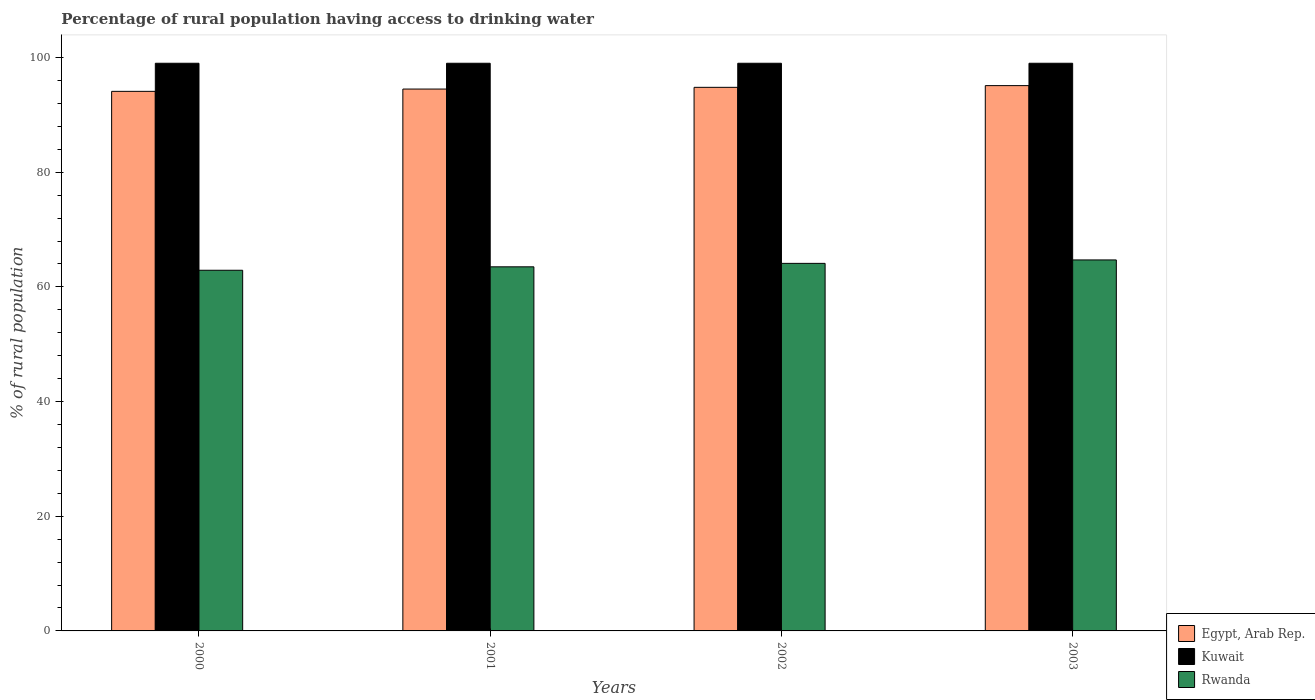How many different coloured bars are there?
Make the answer very short. 3. How many groups of bars are there?
Offer a very short reply. 4. How many bars are there on the 2nd tick from the left?
Your answer should be very brief. 3. How many bars are there on the 1st tick from the right?
Your answer should be compact. 3. In how many cases, is the number of bars for a given year not equal to the number of legend labels?
Ensure brevity in your answer.  0. What is the percentage of rural population having access to drinking water in Kuwait in 2001?
Your response must be concise. 99. Across all years, what is the maximum percentage of rural population having access to drinking water in Rwanda?
Your answer should be compact. 64.7. Across all years, what is the minimum percentage of rural population having access to drinking water in Kuwait?
Offer a very short reply. 99. What is the total percentage of rural population having access to drinking water in Egypt, Arab Rep. in the graph?
Ensure brevity in your answer.  378.5. What is the difference between the percentage of rural population having access to drinking water in Kuwait in 2001 and that in 2002?
Provide a short and direct response. 0. What is the difference between the percentage of rural population having access to drinking water in Kuwait in 2003 and the percentage of rural population having access to drinking water in Egypt, Arab Rep. in 2002?
Your response must be concise. 4.2. In the year 2002, what is the difference between the percentage of rural population having access to drinking water in Rwanda and percentage of rural population having access to drinking water in Kuwait?
Offer a very short reply. -34.9. What is the ratio of the percentage of rural population having access to drinking water in Rwanda in 2000 to that in 2003?
Your response must be concise. 0.97. Is the difference between the percentage of rural population having access to drinking water in Rwanda in 2000 and 2001 greater than the difference between the percentage of rural population having access to drinking water in Kuwait in 2000 and 2001?
Offer a very short reply. No. What is the difference between the highest and the second highest percentage of rural population having access to drinking water in Egypt, Arab Rep.?
Offer a very short reply. 0.3. What does the 2nd bar from the left in 2000 represents?
Provide a succinct answer. Kuwait. What does the 1st bar from the right in 2003 represents?
Keep it short and to the point. Rwanda. How many years are there in the graph?
Offer a terse response. 4. Are the values on the major ticks of Y-axis written in scientific E-notation?
Provide a succinct answer. No. Does the graph contain any zero values?
Your response must be concise. No. Does the graph contain grids?
Your response must be concise. No. How many legend labels are there?
Your answer should be compact. 3. What is the title of the graph?
Offer a terse response. Percentage of rural population having access to drinking water. Does "Samoa" appear as one of the legend labels in the graph?
Offer a very short reply. No. What is the label or title of the Y-axis?
Provide a succinct answer. % of rural population. What is the % of rural population of Egypt, Arab Rep. in 2000?
Provide a succinct answer. 94.1. What is the % of rural population in Kuwait in 2000?
Offer a terse response. 99. What is the % of rural population in Rwanda in 2000?
Provide a short and direct response. 62.9. What is the % of rural population of Egypt, Arab Rep. in 2001?
Offer a very short reply. 94.5. What is the % of rural population of Kuwait in 2001?
Your response must be concise. 99. What is the % of rural population in Rwanda in 2001?
Keep it short and to the point. 63.5. What is the % of rural population of Egypt, Arab Rep. in 2002?
Keep it short and to the point. 94.8. What is the % of rural population in Rwanda in 2002?
Keep it short and to the point. 64.1. What is the % of rural population in Egypt, Arab Rep. in 2003?
Give a very brief answer. 95.1. What is the % of rural population of Rwanda in 2003?
Offer a terse response. 64.7. Across all years, what is the maximum % of rural population in Egypt, Arab Rep.?
Your answer should be compact. 95.1. Across all years, what is the maximum % of rural population in Rwanda?
Your response must be concise. 64.7. Across all years, what is the minimum % of rural population in Egypt, Arab Rep.?
Ensure brevity in your answer.  94.1. Across all years, what is the minimum % of rural population of Kuwait?
Offer a very short reply. 99. Across all years, what is the minimum % of rural population of Rwanda?
Ensure brevity in your answer.  62.9. What is the total % of rural population of Egypt, Arab Rep. in the graph?
Your answer should be compact. 378.5. What is the total % of rural population of Kuwait in the graph?
Give a very brief answer. 396. What is the total % of rural population of Rwanda in the graph?
Make the answer very short. 255.2. What is the difference between the % of rural population of Kuwait in 2000 and that in 2001?
Keep it short and to the point. 0. What is the difference between the % of rural population in Kuwait in 2000 and that in 2002?
Ensure brevity in your answer.  0. What is the difference between the % of rural population in Rwanda in 2000 and that in 2002?
Provide a succinct answer. -1.2. What is the difference between the % of rural population in Egypt, Arab Rep. in 2000 and that in 2003?
Offer a very short reply. -1. What is the difference between the % of rural population in Kuwait in 2000 and that in 2003?
Provide a short and direct response. 0. What is the difference between the % of rural population of Rwanda in 2001 and that in 2002?
Provide a succinct answer. -0.6. What is the difference between the % of rural population in Kuwait in 2001 and that in 2003?
Give a very brief answer. 0. What is the difference between the % of rural population in Egypt, Arab Rep. in 2002 and that in 2003?
Offer a very short reply. -0.3. What is the difference between the % of rural population in Rwanda in 2002 and that in 2003?
Offer a terse response. -0.6. What is the difference between the % of rural population of Egypt, Arab Rep. in 2000 and the % of rural population of Kuwait in 2001?
Provide a succinct answer. -4.9. What is the difference between the % of rural population of Egypt, Arab Rep. in 2000 and the % of rural population of Rwanda in 2001?
Your response must be concise. 30.6. What is the difference between the % of rural population in Kuwait in 2000 and the % of rural population in Rwanda in 2001?
Offer a terse response. 35.5. What is the difference between the % of rural population in Egypt, Arab Rep. in 2000 and the % of rural population in Kuwait in 2002?
Your answer should be compact. -4.9. What is the difference between the % of rural population of Egypt, Arab Rep. in 2000 and the % of rural population of Rwanda in 2002?
Your response must be concise. 30. What is the difference between the % of rural population of Kuwait in 2000 and the % of rural population of Rwanda in 2002?
Offer a very short reply. 34.9. What is the difference between the % of rural population of Egypt, Arab Rep. in 2000 and the % of rural population of Rwanda in 2003?
Ensure brevity in your answer.  29.4. What is the difference between the % of rural population of Kuwait in 2000 and the % of rural population of Rwanda in 2003?
Make the answer very short. 34.3. What is the difference between the % of rural population of Egypt, Arab Rep. in 2001 and the % of rural population of Rwanda in 2002?
Give a very brief answer. 30.4. What is the difference between the % of rural population in Kuwait in 2001 and the % of rural population in Rwanda in 2002?
Keep it short and to the point. 34.9. What is the difference between the % of rural population of Egypt, Arab Rep. in 2001 and the % of rural population of Kuwait in 2003?
Offer a terse response. -4.5. What is the difference between the % of rural population in Egypt, Arab Rep. in 2001 and the % of rural population in Rwanda in 2003?
Keep it short and to the point. 29.8. What is the difference between the % of rural population in Kuwait in 2001 and the % of rural population in Rwanda in 2003?
Provide a short and direct response. 34.3. What is the difference between the % of rural population in Egypt, Arab Rep. in 2002 and the % of rural population in Rwanda in 2003?
Provide a short and direct response. 30.1. What is the difference between the % of rural population in Kuwait in 2002 and the % of rural population in Rwanda in 2003?
Make the answer very short. 34.3. What is the average % of rural population in Egypt, Arab Rep. per year?
Keep it short and to the point. 94.62. What is the average % of rural population of Kuwait per year?
Your answer should be compact. 99. What is the average % of rural population in Rwanda per year?
Give a very brief answer. 63.8. In the year 2000, what is the difference between the % of rural population in Egypt, Arab Rep. and % of rural population in Rwanda?
Your answer should be compact. 31.2. In the year 2000, what is the difference between the % of rural population of Kuwait and % of rural population of Rwanda?
Provide a short and direct response. 36.1. In the year 2001, what is the difference between the % of rural population in Kuwait and % of rural population in Rwanda?
Provide a succinct answer. 35.5. In the year 2002, what is the difference between the % of rural population in Egypt, Arab Rep. and % of rural population in Kuwait?
Ensure brevity in your answer.  -4.2. In the year 2002, what is the difference between the % of rural population in Egypt, Arab Rep. and % of rural population in Rwanda?
Your answer should be compact. 30.7. In the year 2002, what is the difference between the % of rural population of Kuwait and % of rural population of Rwanda?
Make the answer very short. 34.9. In the year 2003, what is the difference between the % of rural population of Egypt, Arab Rep. and % of rural population of Rwanda?
Give a very brief answer. 30.4. In the year 2003, what is the difference between the % of rural population in Kuwait and % of rural population in Rwanda?
Ensure brevity in your answer.  34.3. What is the ratio of the % of rural population of Rwanda in 2000 to that in 2001?
Offer a terse response. 0.99. What is the ratio of the % of rural population of Egypt, Arab Rep. in 2000 to that in 2002?
Your response must be concise. 0.99. What is the ratio of the % of rural population in Kuwait in 2000 to that in 2002?
Give a very brief answer. 1. What is the ratio of the % of rural population in Rwanda in 2000 to that in 2002?
Provide a succinct answer. 0.98. What is the ratio of the % of rural population in Rwanda in 2000 to that in 2003?
Offer a terse response. 0.97. What is the ratio of the % of rural population in Kuwait in 2001 to that in 2002?
Offer a terse response. 1. What is the ratio of the % of rural population in Rwanda in 2001 to that in 2002?
Keep it short and to the point. 0.99. What is the ratio of the % of rural population of Egypt, Arab Rep. in 2001 to that in 2003?
Your answer should be compact. 0.99. What is the ratio of the % of rural population of Kuwait in 2001 to that in 2003?
Your answer should be compact. 1. What is the ratio of the % of rural population of Rwanda in 2001 to that in 2003?
Provide a succinct answer. 0.98. What is the ratio of the % of rural population of Egypt, Arab Rep. in 2002 to that in 2003?
Keep it short and to the point. 1. What is the ratio of the % of rural population of Rwanda in 2002 to that in 2003?
Your response must be concise. 0.99. What is the difference between the highest and the lowest % of rural population of Kuwait?
Your response must be concise. 0. 